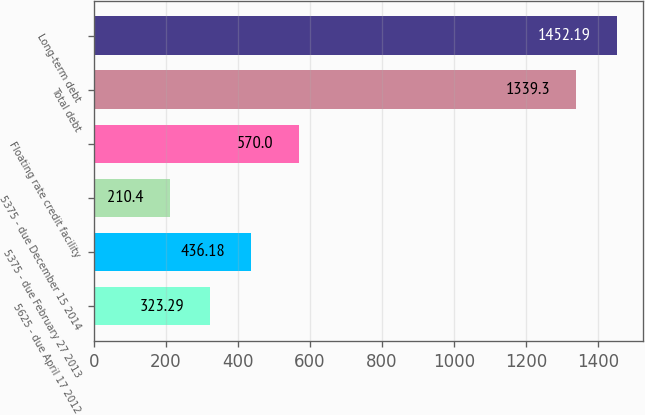Convert chart to OTSL. <chart><loc_0><loc_0><loc_500><loc_500><bar_chart><fcel>5625 - due April 17 2012<fcel>5375 - due February 27 2013<fcel>5375 - due December 15 2014<fcel>Floating rate credit facility<fcel>Total debt<fcel>Long-term debt<nl><fcel>323.29<fcel>436.18<fcel>210.4<fcel>570<fcel>1339.3<fcel>1452.19<nl></chart> 